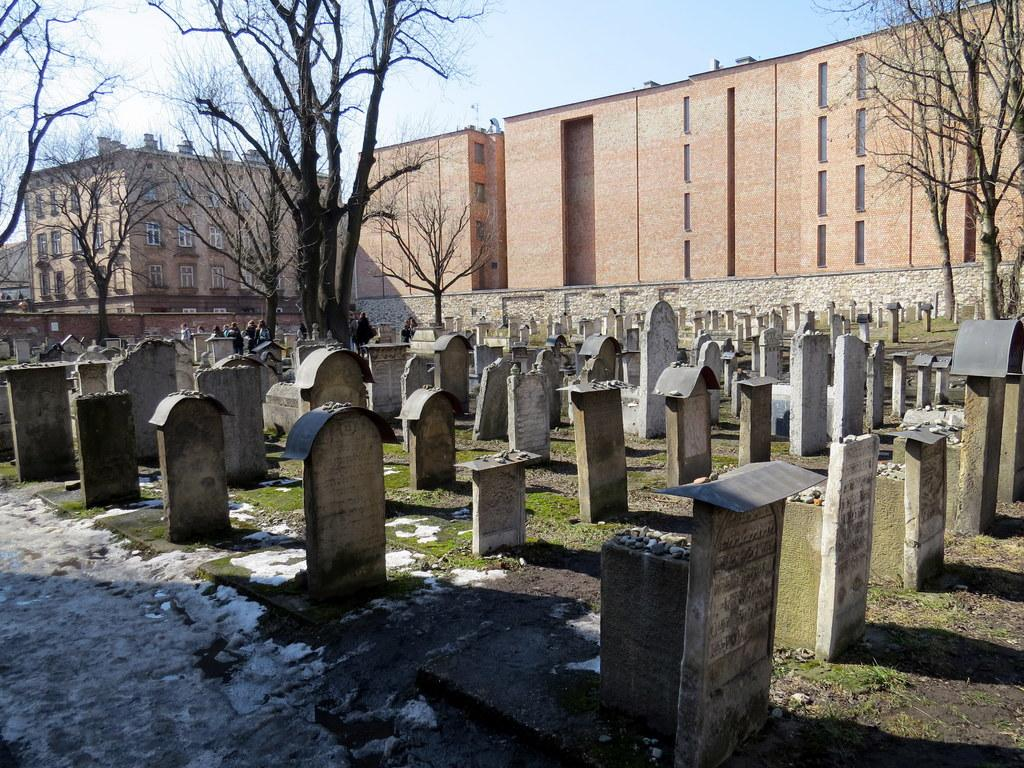How many people are in the image? There is a group of people in the image. What is the setting of the image? The image features a graveyard. What type of vegetation is present in the image? There are trees in the image. What type of structures can be seen in the image? There are buildings in the image. What is visible in the background of the image? The sky is visible in the background of the image. What title is given to the scarecrow in the image? There is no scarecrow present in the image. What is the end result of the people's actions in the image? The image does not depict any actions or events that have a specific end result. 